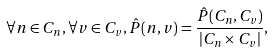<formula> <loc_0><loc_0><loc_500><loc_500>\forall n \in C _ { n } , \forall v \in C _ { v } , \hat { P } ( n , v ) = \frac { \hat { P } ( C _ { n } , C _ { v } ) } { | C _ { n } \times C _ { v } | } ,</formula> 